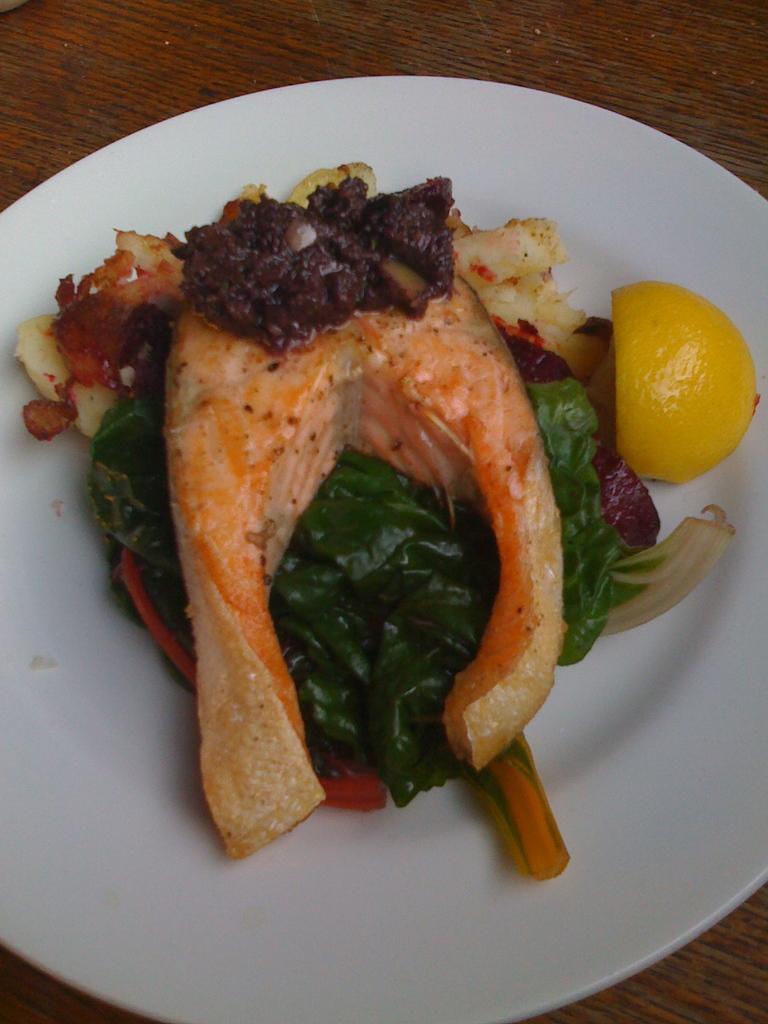In one or two sentences, can you explain what this image depicts? In the foreground of this image, there is a meat and few leafy vegetables and a piece of lemon on a platter which is on a wooden surface. 